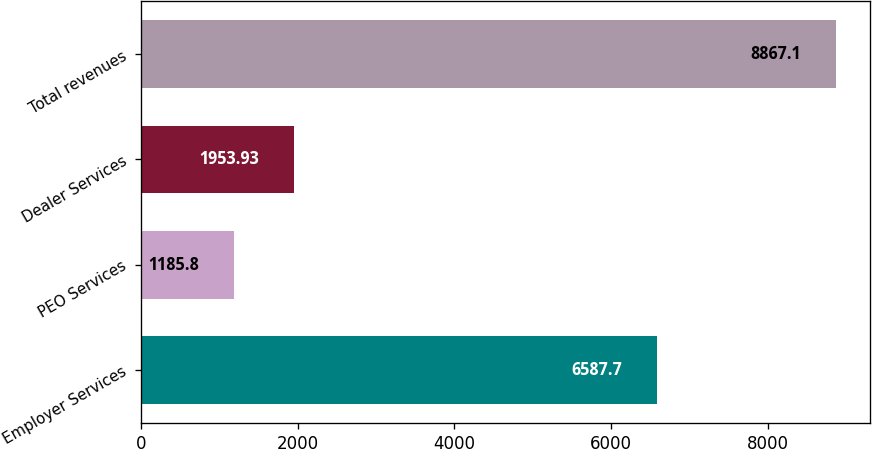Convert chart to OTSL. <chart><loc_0><loc_0><loc_500><loc_500><bar_chart><fcel>Employer Services<fcel>PEO Services<fcel>Dealer Services<fcel>Total revenues<nl><fcel>6587.7<fcel>1185.8<fcel>1953.93<fcel>8867.1<nl></chart> 